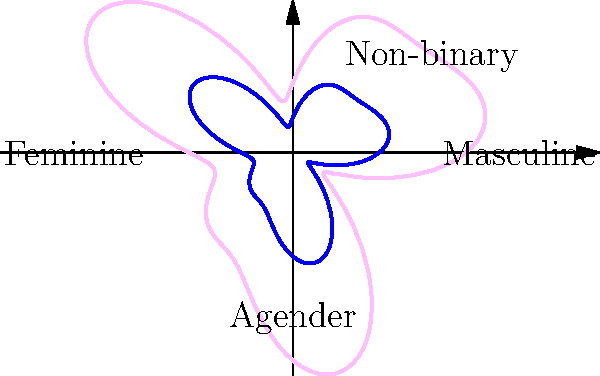In the asymmetrical polar shape representing a gender identity spectrum, what is the ratio of the maximum radial distance in the "feminine" direction (left) to the maximum radial distance in the "masculine" direction (right)? To solve this problem, we need to follow these steps:

1. Identify the function used to create the polar shape:
   $r(\theta) = 2 + \sin(3\theta) + 0.5\cos(5\theta)$

2. Find the angle $\theta$ for the "feminine" direction (left):
   $\theta_f = \pi$ (180 degrees)

3. Find the angle $\theta$ for the "masculine" direction (right):
   $\theta_m = 0$ (0 degrees)

4. Calculate the radial distance for the "feminine" direction:
   $r_f = r(\pi) = 2 + \sin(3\pi) + 0.5\cos(5\pi) = 2 + 0 - 0.5 = 1.5$

5. Calculate the radial distance for the "masculine" direction:
   $r_m = r(0) = 2 + \sin(0) + 0.5\cos(0) = 2 + 0 + 0.5 = 2.5$

6. Calculate the ratio of feminine to masculine radial distances:
   $\text{ratio} = \frac{r_f}{r_m} = \frac{1.5}{2.5} = 0.6$

Therefore, the ratio of the maximum radial distance in the "feminine" direction to the maximum radial distance in the "masculine" direction is 0.6 or 3:5.
Answer: 0.6 